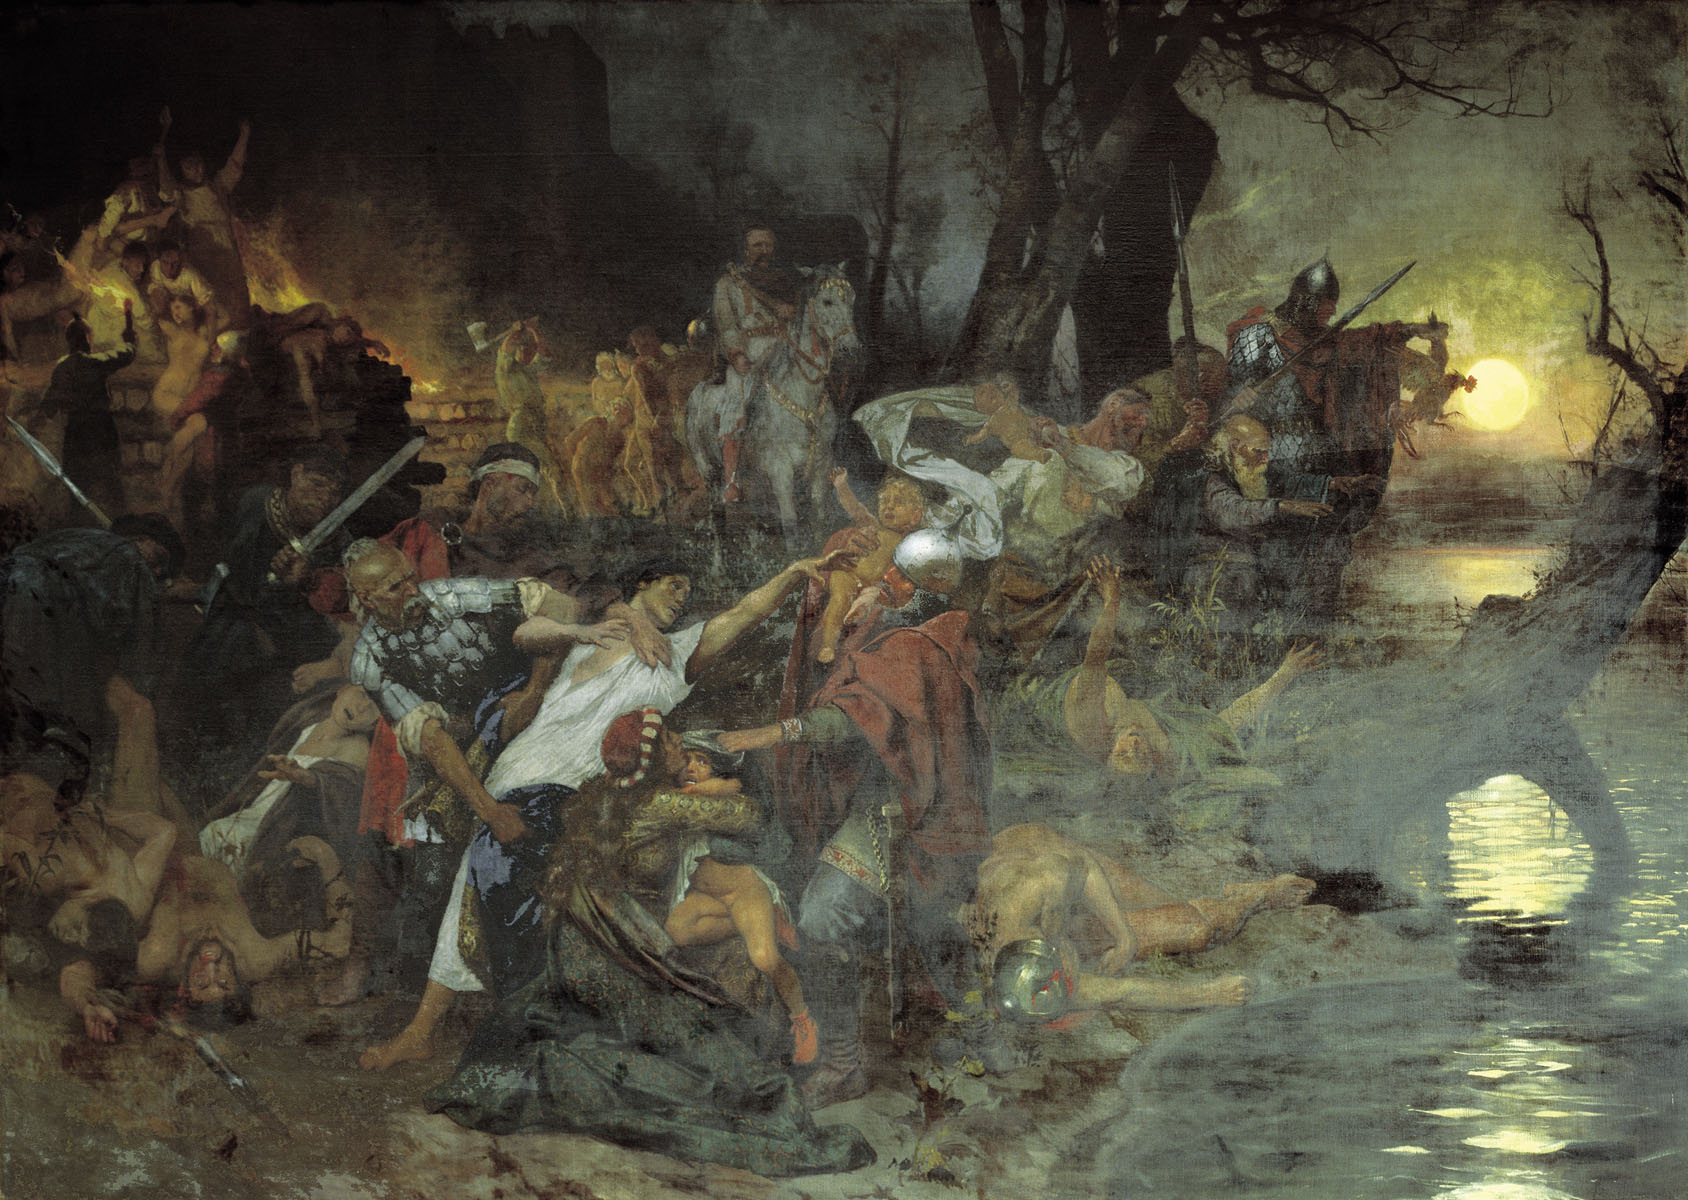Can you describe the role of color in this artwork? Color plays a crucial role in conveying the emotional depth and thematic essence of this painting. The use of dark, somber tones sets a tragic and intense mood, emphasizing the seriousness of the battle. The contrasting bright yellows of the moon and fires in the scene not only guide the viewer's eye through the chaos but also highlight key actions and emotions. These stark contrasts enhance the dramatic impact of the painting, underlining the extremity of human conflicts and the stark realities of war. 